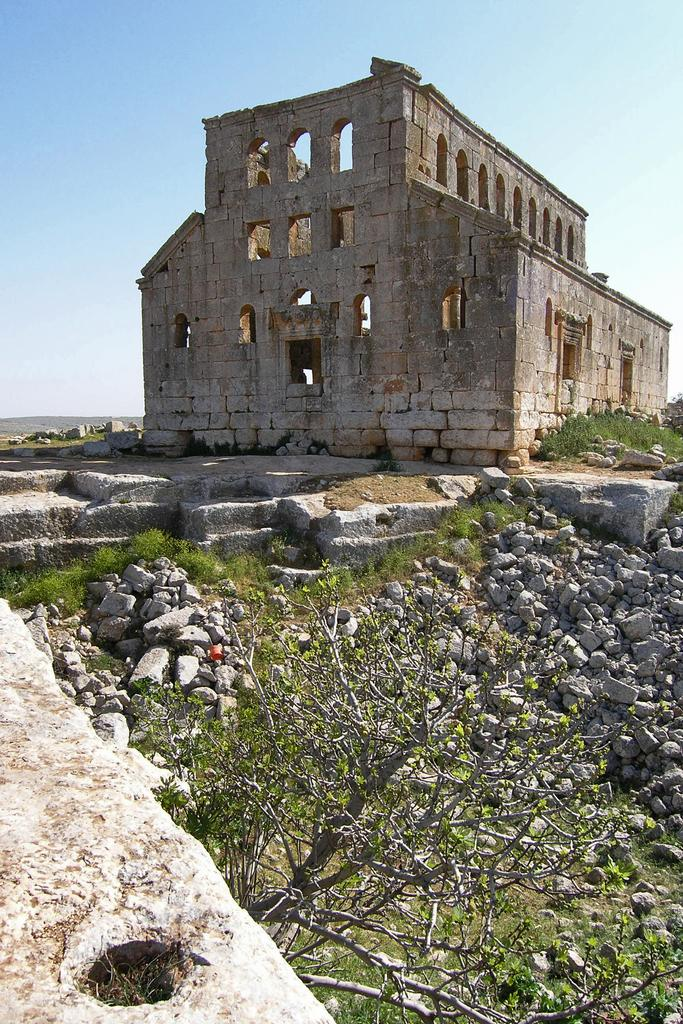What type of natural element is present in the image? There is a tree in the image. What other objects can be seen in the image? There are rocks in the image. What structure is located in the center of the image? There is a building in the center of the image. What is visible in the background of the image? The sky is visible in the background of the image. What type of insurance policy is being discussed in the image? There is no discussion of insurance policies in the image; it features include a tree, rocks, a building, and the sky. Can you tell me how many bombs are present in the image? There are no bombs present in the image; it features a tree, rocks, a building, and the sky. 